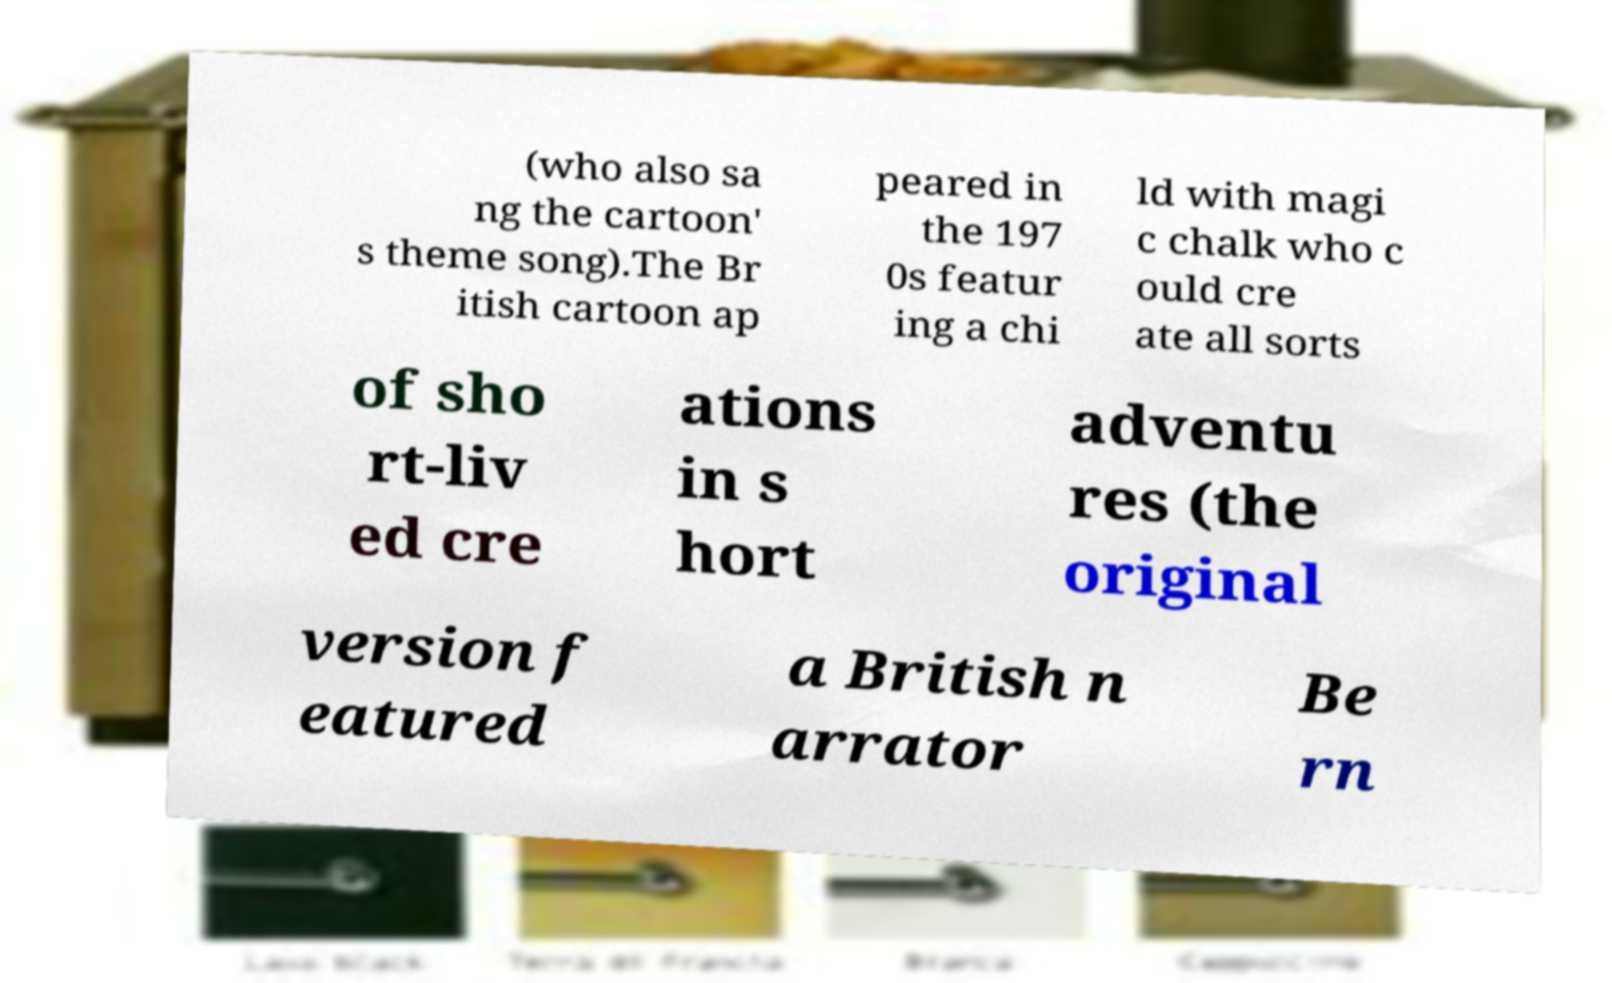Could you assist in decoding the text presented in this image and type it out clearly? (who also sa ng the cartoon' s theme song).The Br itish cartoon ap peared in the 197 0s featur ing a chi ld with magi c chalk who c ould cre ate all sorts of sho rt-liv ed cre ations in s hort adventu res (the original version f eatured a British n arrator Be rn 